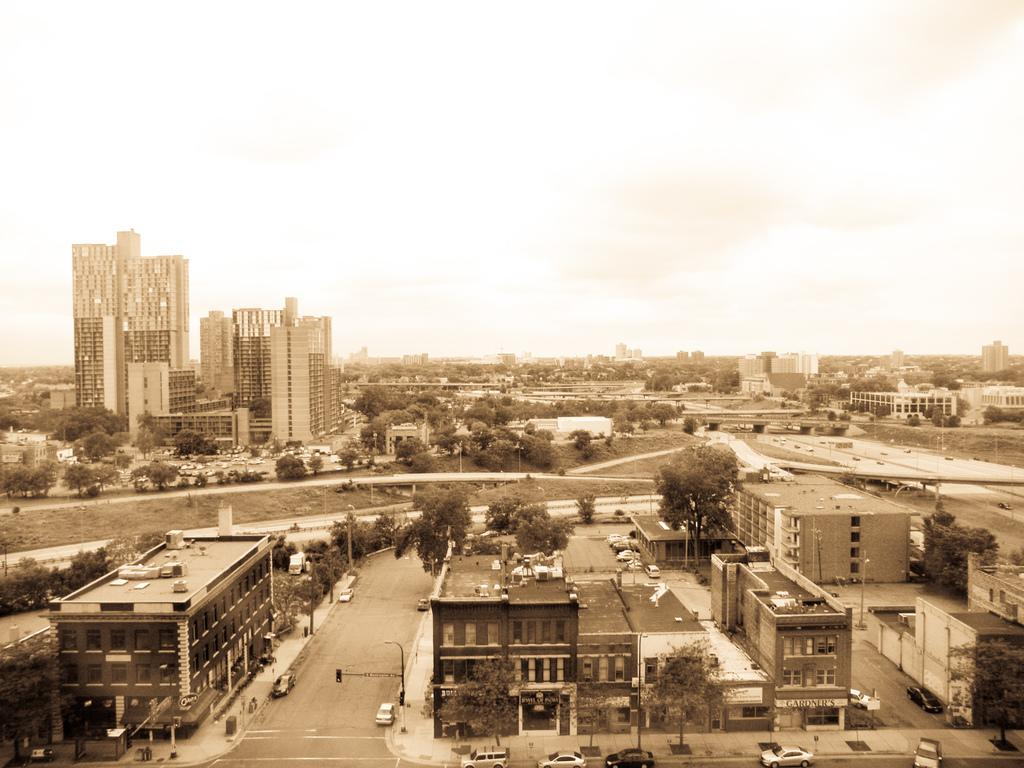What type of structures can be seen in the image? There are many buildings in the image. What else is present in the image besides buildings? There are vehicles and trees visible in the image. What can be seen in the background of the image? The sky is visible in the background of the image. What color is the balloon floating above the buildings in the image? There is no balloon present in the image. What type of current is affecting the vehicles in the image? There is no information about any current affecting the vehicles in the image. 